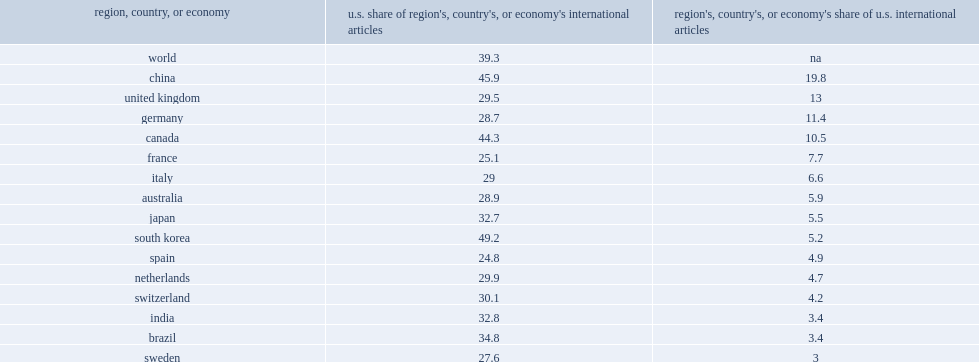How many percent did researchers in china account of u.s. internationally coauthored publications in 2014? 19.8. How many percent did data on international collaboration of other countries indicate that publications from authors from south korea are notable for having high collaboration rates with u.s. authors? 49.2. How many percent did data on international collaboration of other countries indicate that publications from authors from china are notable for having high collaboration rates with u.s. authors? 45.9. How many percent did data on international collaboration of other countries indicate that publications from authors from canada are notable for having high collaboration rates with u.s. authors? 44.3. 